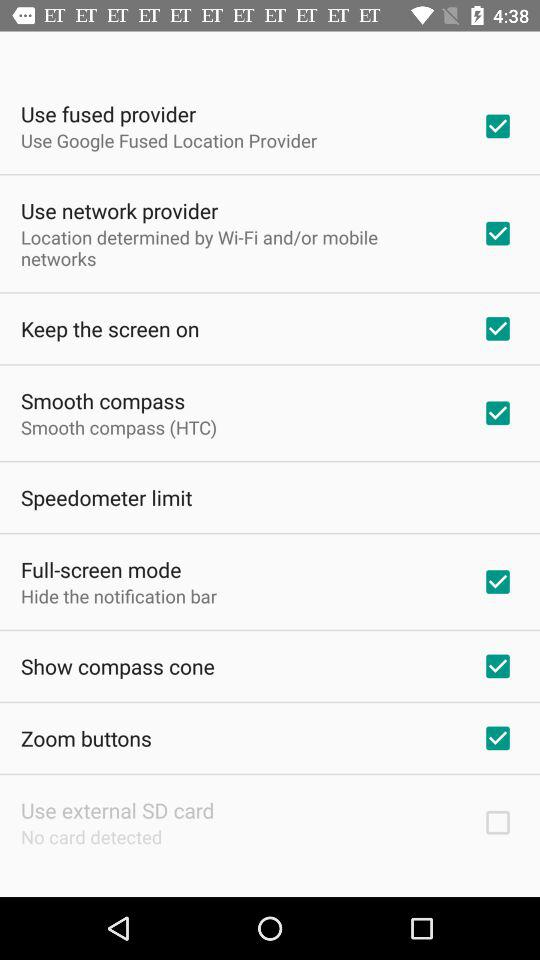What's the status of "Smooth compass"? The status is "on". 